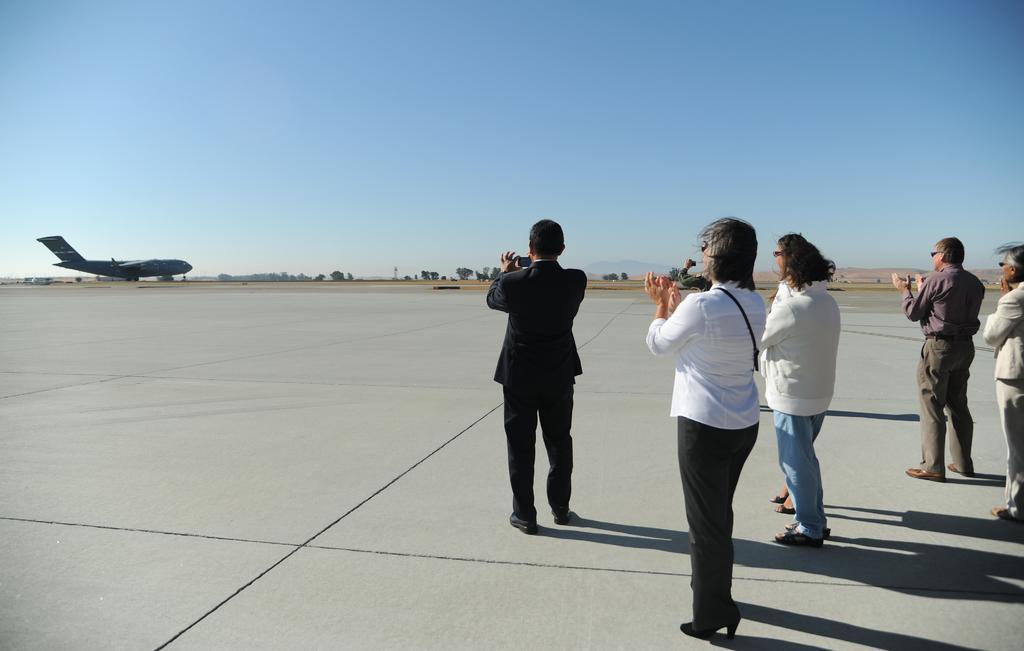Describe this image in one or two sentences. There are few people standing in the right corner where one among them is holding a camera in his hand and there is a plane in front of them and there are trees in the background. 